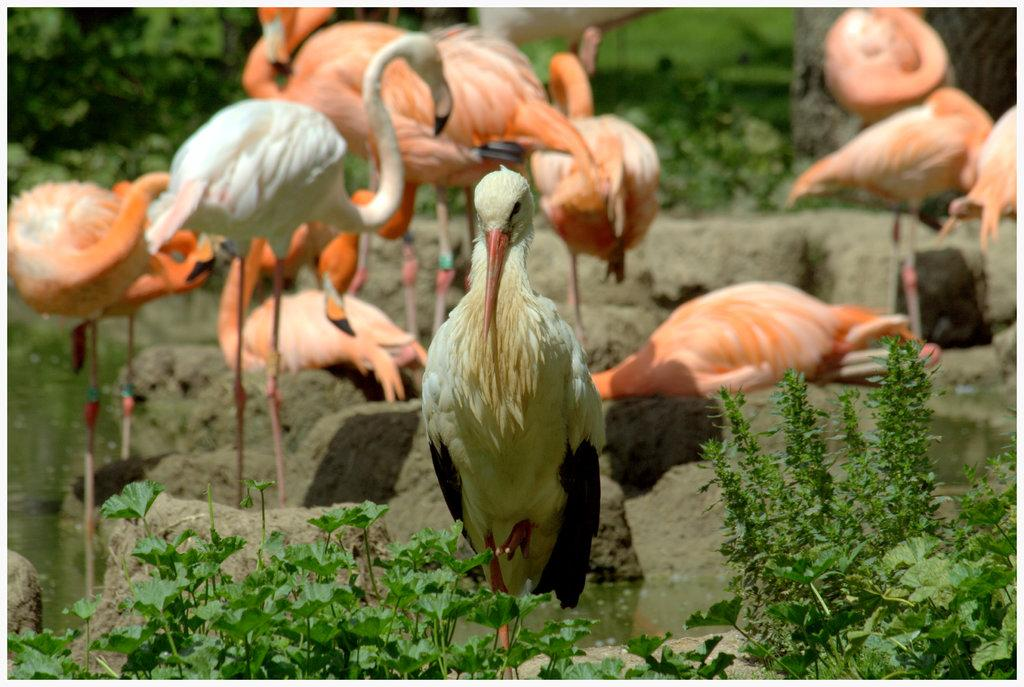What animals are present in the image? There are swans in the image. What can be found at the bottom of the image? There are plants and stones at the bottom of the image. What is visible in the image besides the swans and plants? There is water visible in the image. What is the color of the background in the image? The background of the image has a green color view. What type of animal is hiding under the cover in the image? There is no cover or animal hiding under it in the image; it features swans in water with plants and stones at the bottom. 